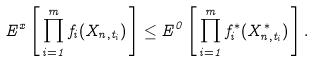Convert formula to latex. <formula><loc_0><loc_0><loc_500><loc_500>E ^ { x } \left [ \, \prod _ { i = 1 } ^ { m } f _ { i } ( X _ { n , t _ { i } } ) \, \right ] \leq E ^ { 0 } \left [ \, \prod _ { i = 1 } ^ { m } f ^ { * } _ { i } ( X ^ { * } _ { n , t _ { i } } ) \, \right ] .</formula> 